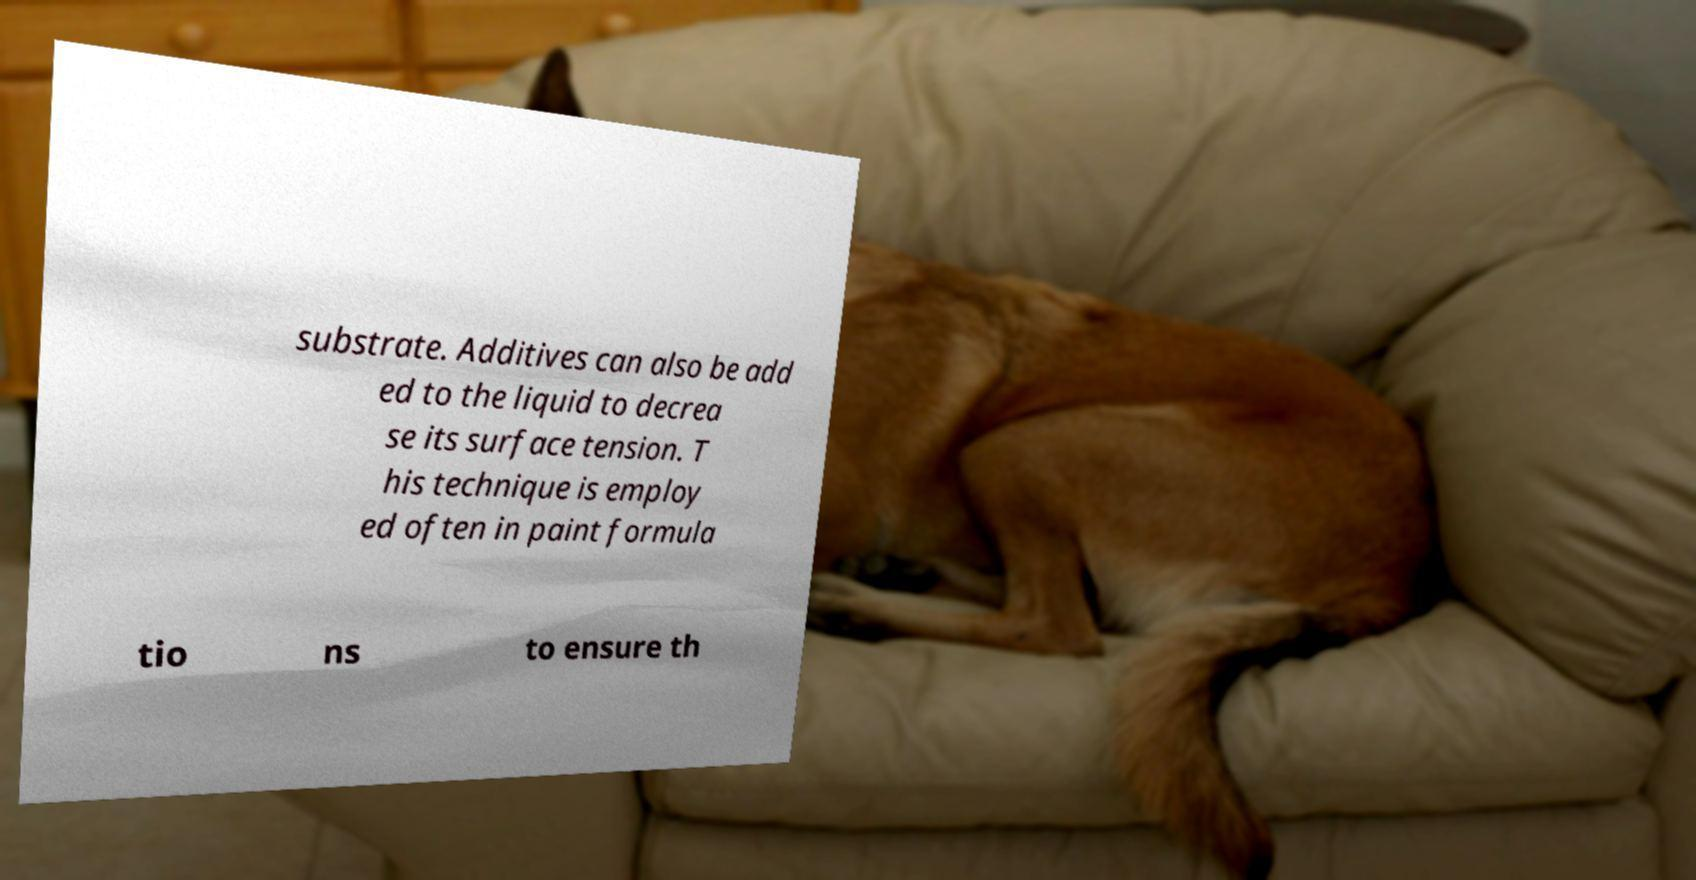There's text embedded in this image that I need extracted. Can you transcribe it verbatim? substrate. Additives can also be add ed to the liquid to decrea se its surface tension. T his technique is employ ed often in paint formula tio ns to ensure th 